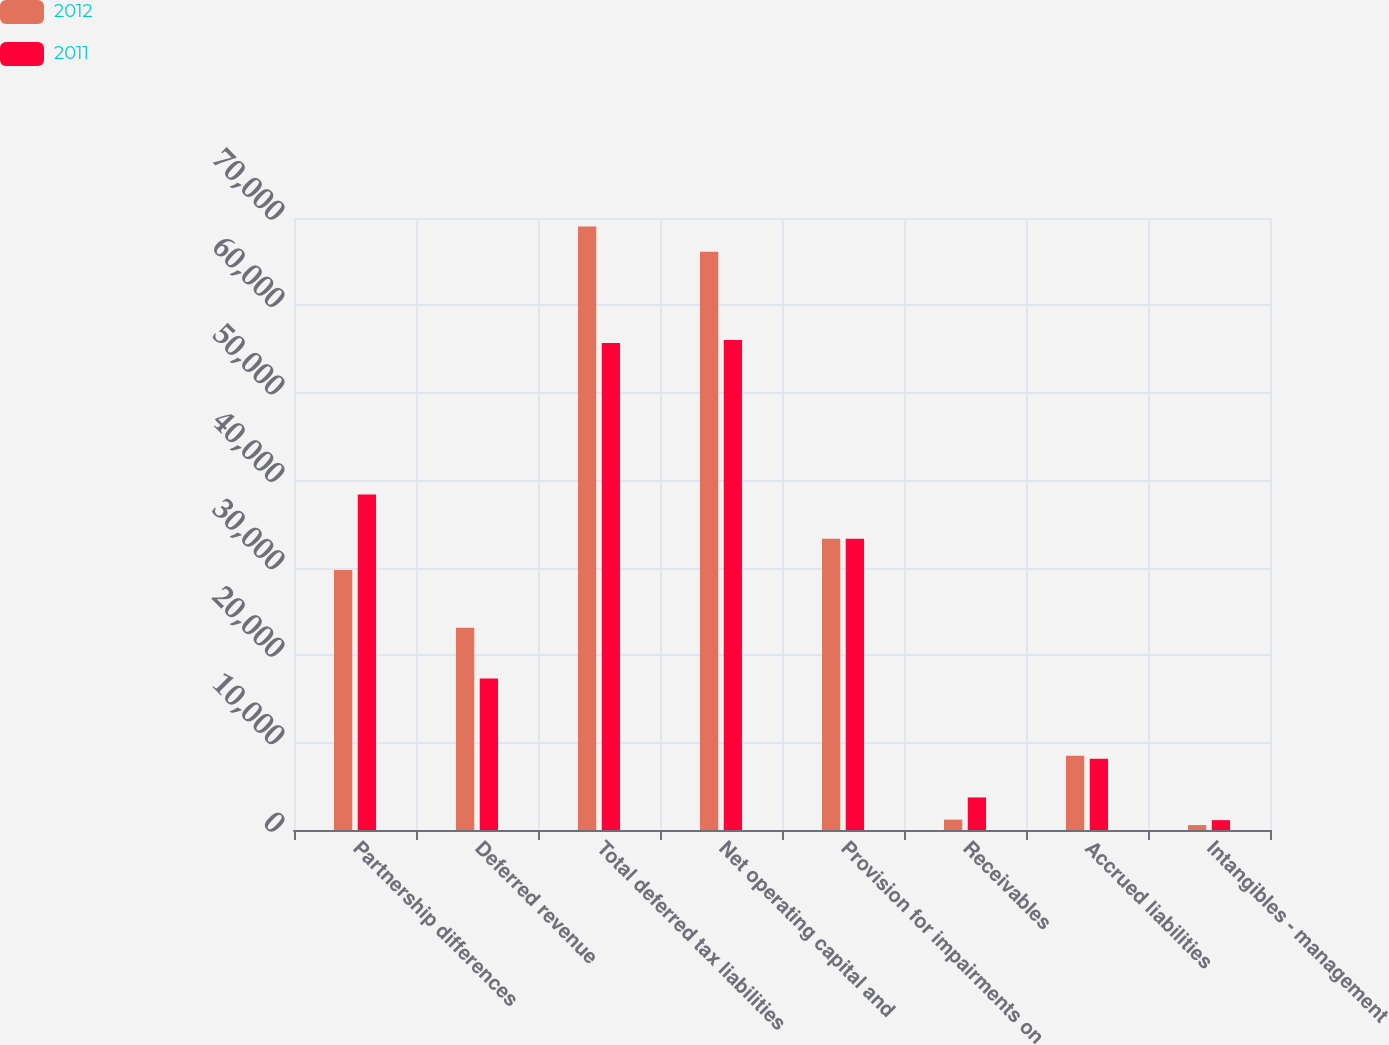Convert chart to OTSL. <chart><loc_0><loc_0><loc_500><loc_500><stacked_bar_chart><ecel><fcel>Partnership differences<fcel>Deferred revenue<fcel>Total deferred tax liabilities<fcel>Net operating capital and<fcel>Provision for impairments on<fcel>Receivables<fcel>Accrued liabilities<fcel>Intangibles - management<nl><fcel>2012<fcel>29745<fcel>23139<fcel>69041<fcel>66145<fcel>33321<fcel>1183<fcel>8500<fcel>561<nl><fcel>2011<fcel>38385<fcel>17326<fcel>55711<fcel>56032<fcel>33321<fcel>3724<fcel>8163<fcel>1126<nl></chart> 